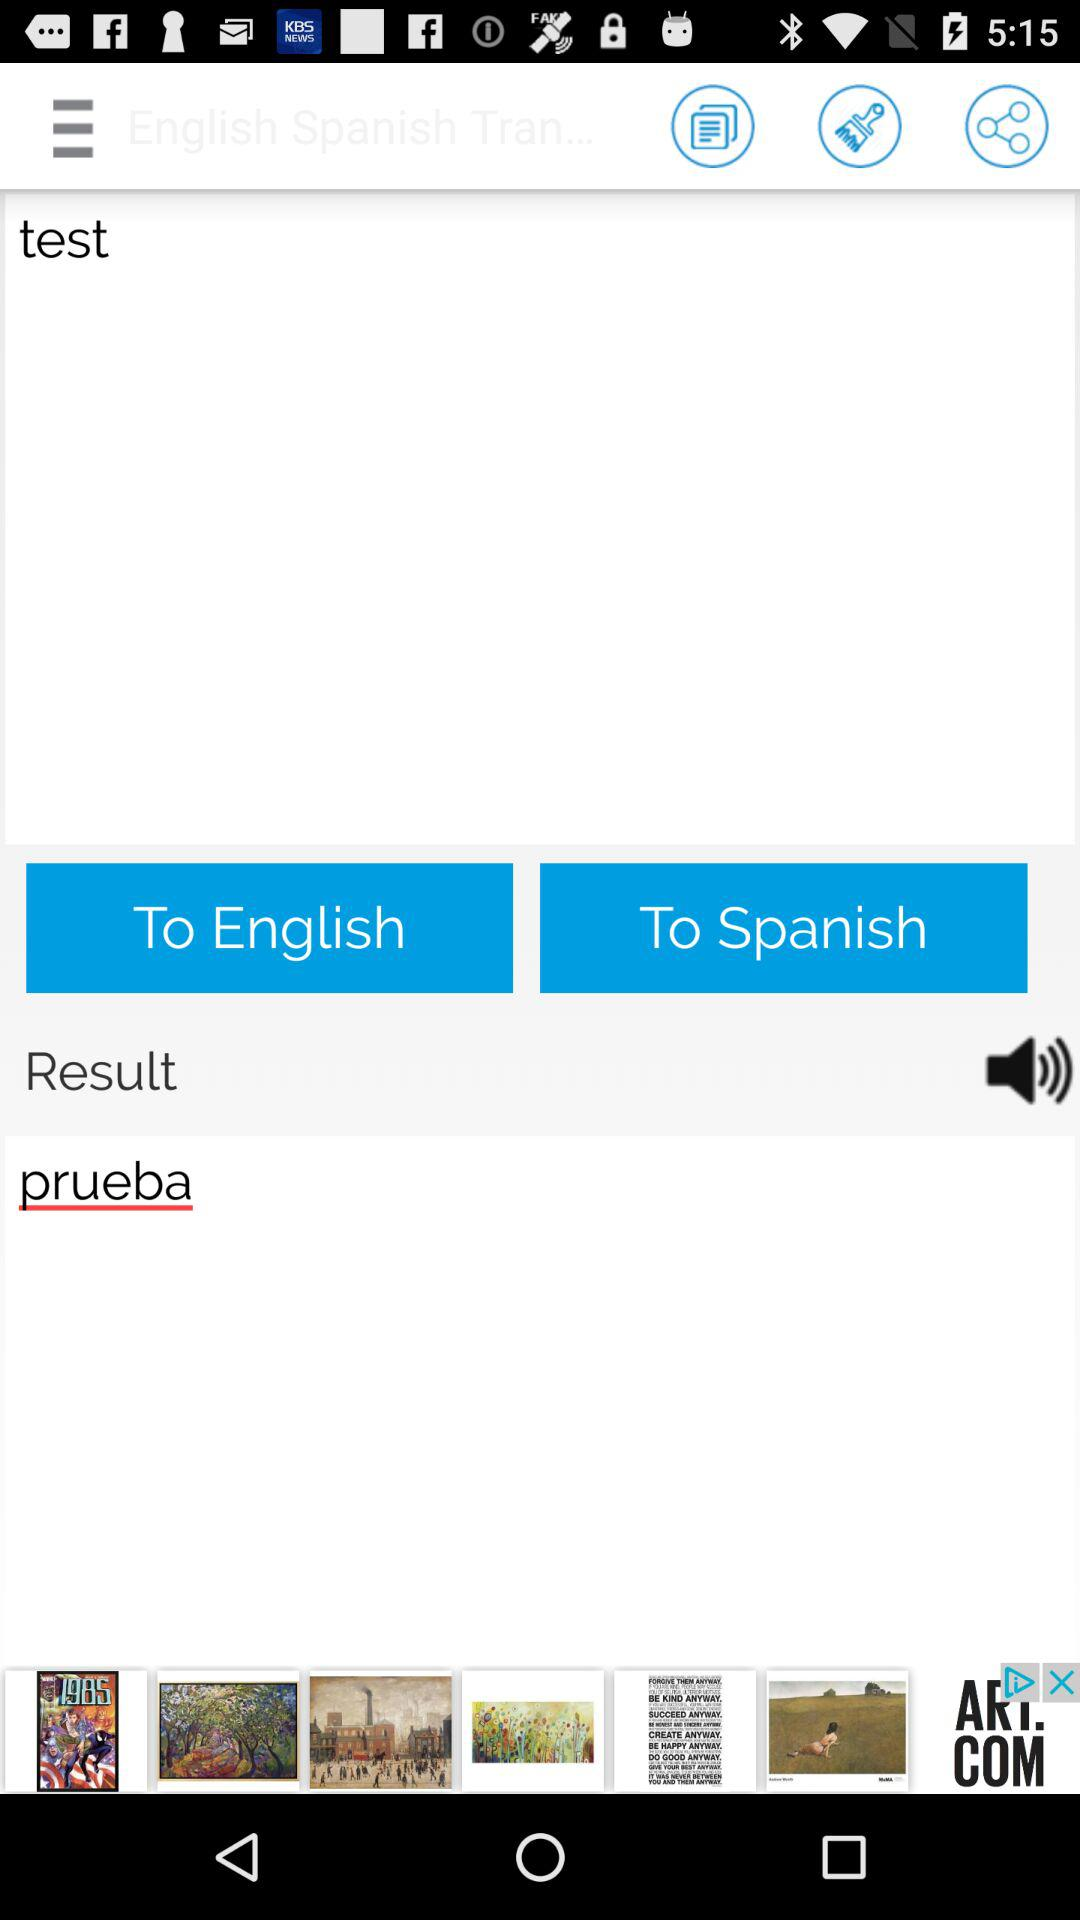What language does it translate to? It translates into Spanish. 